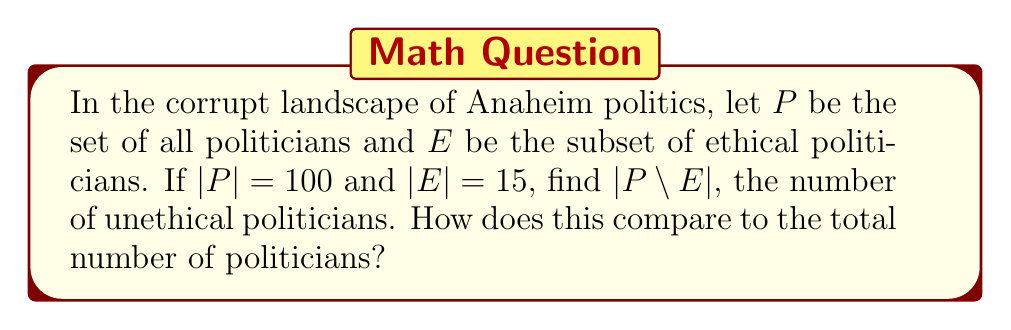Teach me how to tackle this problem. To solve this problem, we need to understand the concept of set complement and how it relates to the given information. Let's break it down step-by-step:

1) We are given:
   $P$ = set of all politicians
   $E$ = set of ethical politicians
   $|P| = 100$ (total number of politicians)
   $|E| = 15$ (number of ethical politicians)

2) We need to find $|P \setminus E|$, which represents the complement of $E$ with respect to $P$. This is the set of all elements in $P$ that are not in $E$, i.e., the unethical politicians.

3) A fundamental set theory principle states that for any set $A$ and its subset $B$:

   $|A| = |B| + |A \setminus B|$

4) Applying this to our problem:

   $|P| = |E| + |P \setminus E|$

5) We can now substitute the known values:

   $100 = 15 + |P \setminus E|$

6) Solving for $|P \setminus E|$:

   $|P \setminus E| = 100 - 15 = 85$

7) To compare this to the total number of politicians:

   Percentage of unethical politicians = $\frac{|P \setminus E|}{|P|} \times 100\% = \frac{85}{100} \times 100\% = 85\%$

This result shows that a staggering 85% of politicians in this scenario are unethical, reflecting the anger and disappointment of the Anaheim resident towards political corruption.
Answer: $|P \setminus E| = 85$, which represents 85% of all politicians. 